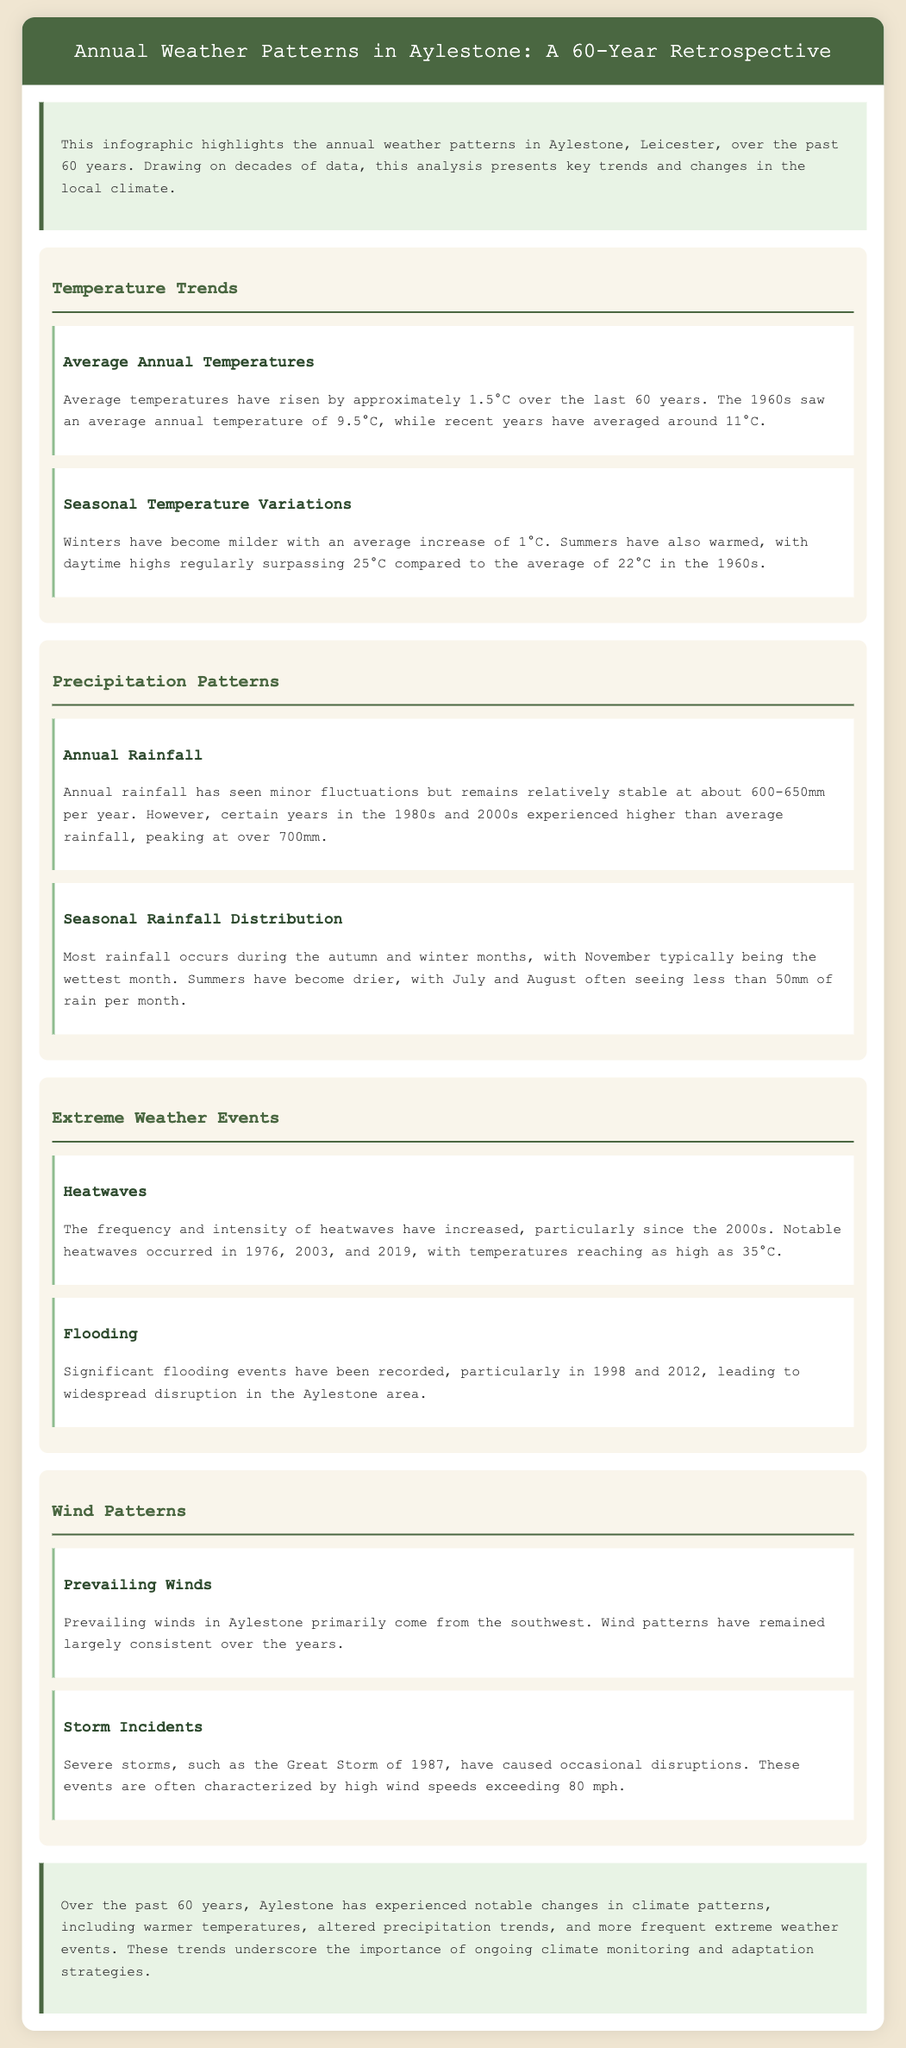what was the average annual temperature in the 1960s? The document states that the average annual temperature in the 1960s was 9.5°C.
Answer: 9.5°C how much have average temperatures risen over the last 60 years? The infographic indicates that average temperatures have risen by approximately 1.5°C.
Answer: 1.5°C which month is typically the wettest in Aylestone? According to the document, November is typically the wettest month.
Answer: November what significant flooding events occurred in Aylestone? The document notes significant flooding events in 1998 and 2012.
Answer: 1998 and 2012 how often do heatwaves occur according to the report? The report mentions that the frequency and intensity of heatwaves have increased, particularly since the 2000s.
Answer: increased what has been the trend in rainfall during summer months? The analysis indicates that summers have become drier, with less than 50mm of rain often in July and August.
Answer: drier which direction do prevailing winds in Aylestone primarily come from? The prevailing winds in Aylestone primarily come from the southwest.
Answer: southwest what high wind speed was noted during severe storms? The document states that severe storms are often characterized by high wind speeds exceeding 80 mph.
Answer: 80 mph what is the overall assessment of climate changes in Aylestone over the past 60 years? The conclusion of the infographic summarizes notable changes in climate patterns, with warmer temperatures and altered precipitation trends.
Answer: notable changes 